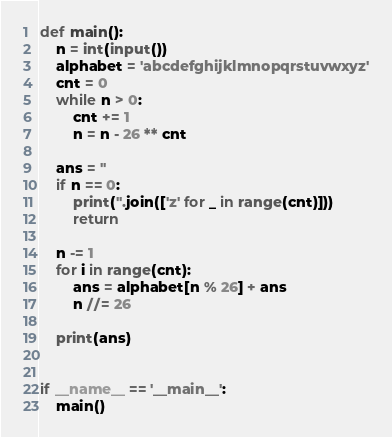<code> <loc_0><loc_0><loc_500><loc_500><_Python_>def main():
    n = int(input())
    alphabet = 'abcdefghijklmnopqrstuvwxyz'
    cnt = 0
    while n > 0:
        cnt += 1
        n = n - 26 ** cnt

    ans = ''
    if n == 0:
        print(''.join(['z' for _ in range(cnt)]))
        return

    n -= 1
    for i in range(cnt):
        ans = alphabet[n % 26] + ans
        n //= 26

    print(ans)


if __name__ == '__main__':
    main()
</code> 